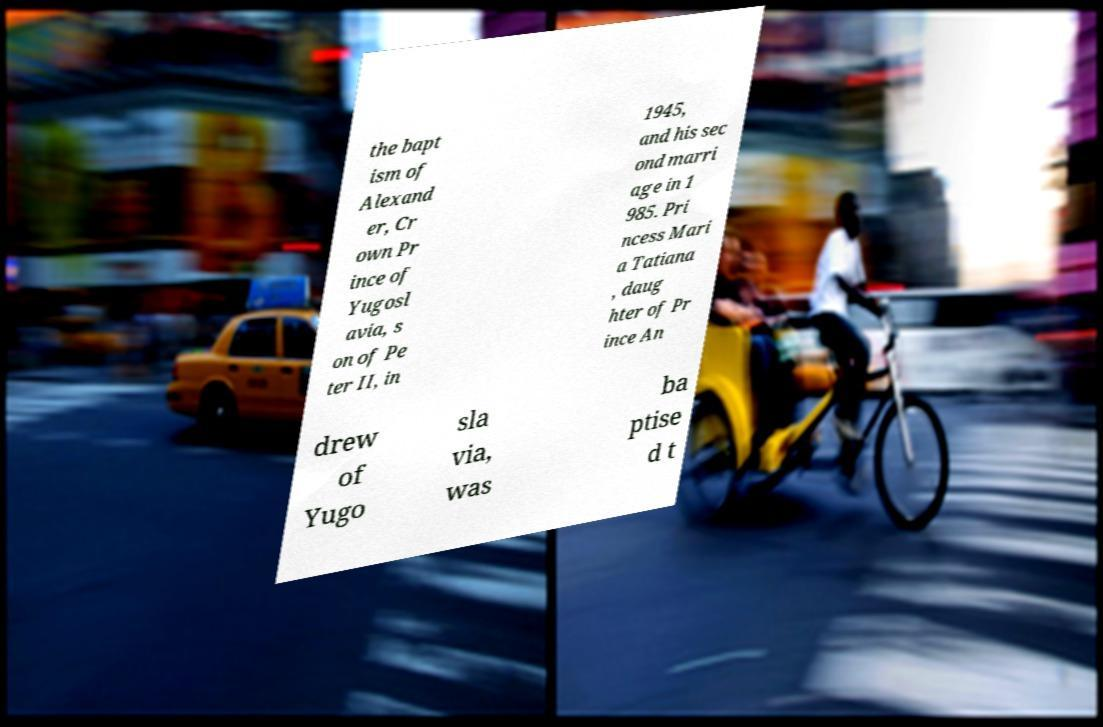What messages or text are displayed in this image? I need them in a readable, typed format. the bapt ism of Alexand er, Cr own Pr ince of Yugosl avia, s on of Pe ter II, in 1945, and his sec ond marri age in 1 985. Pri ncess Mari a Tatiana , daug hter of Pr ince An drew of Yugo sla via, was ba ptise d t 